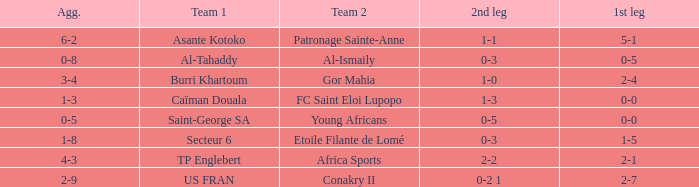Which teams had an aggregate score of 3-4? Burri Khartoum. 